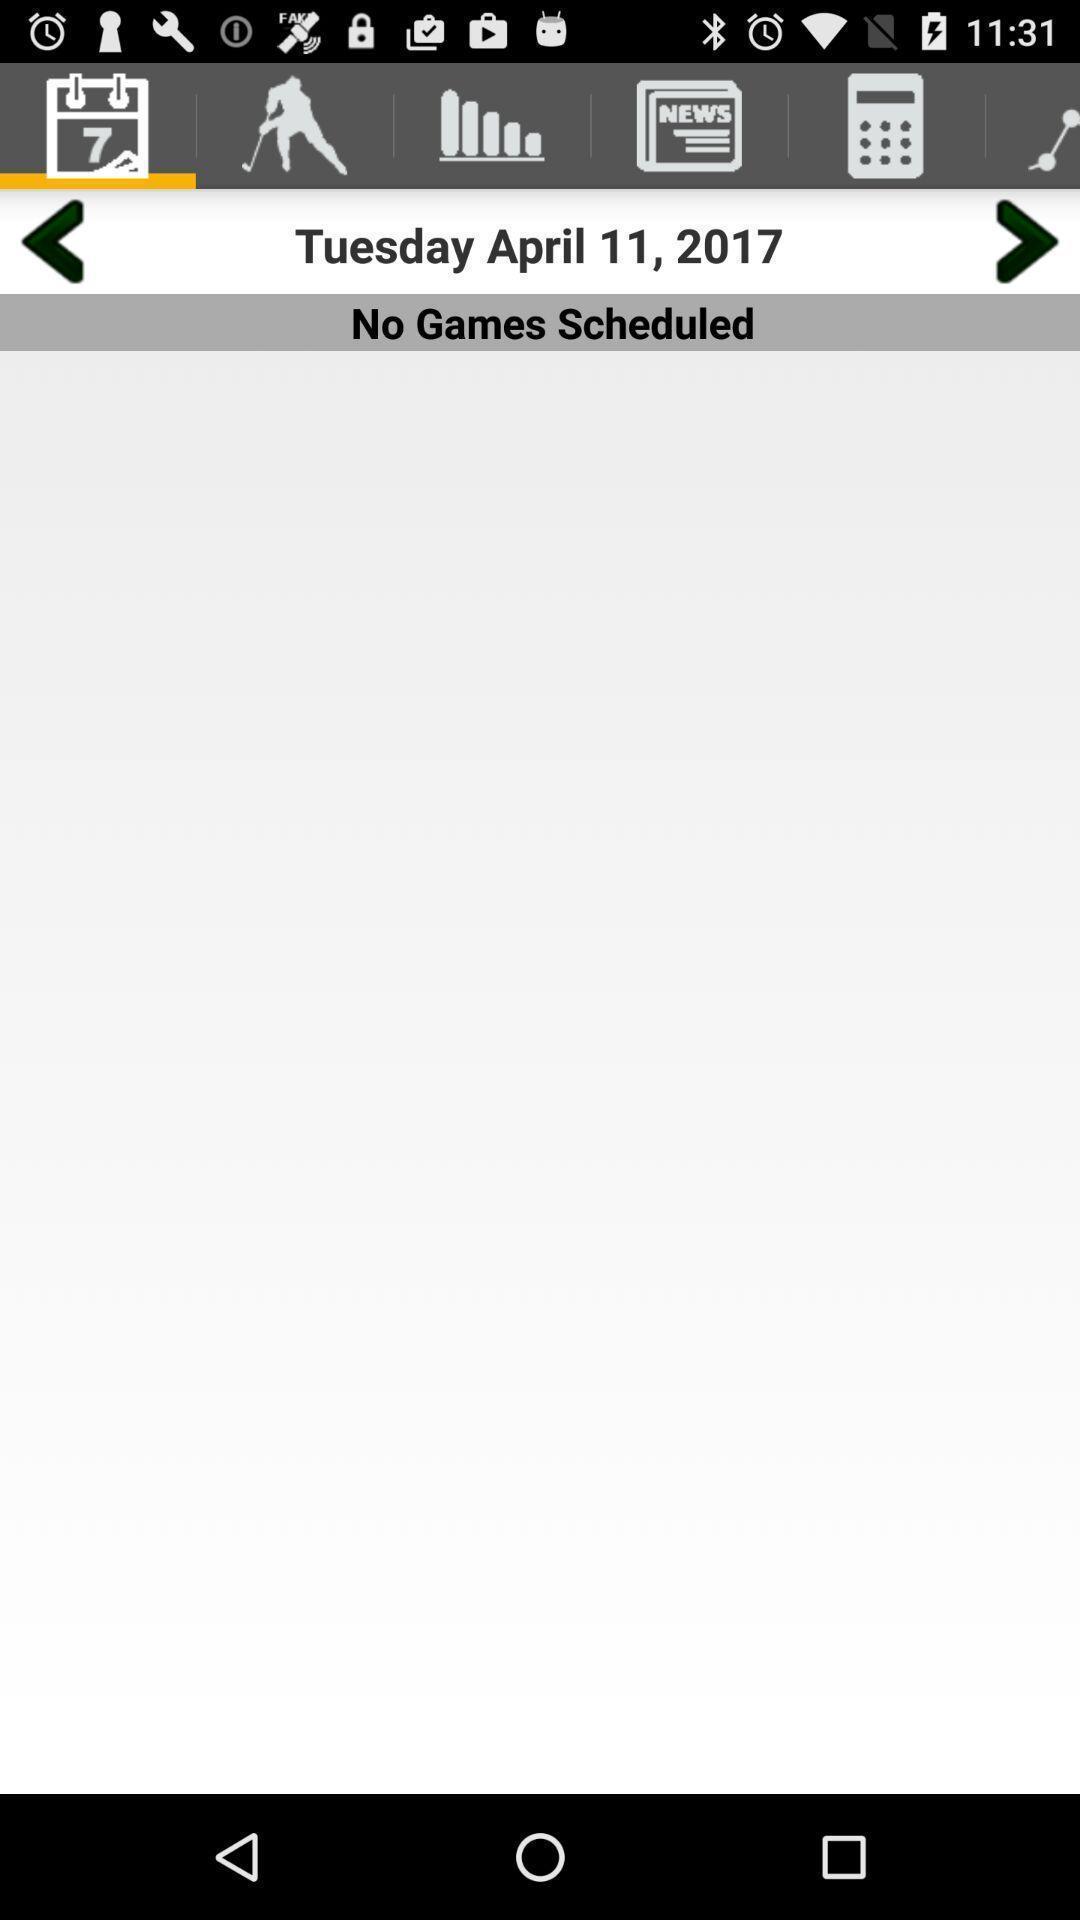Describe this image in words. Page displays blank schedule in gaming app. 